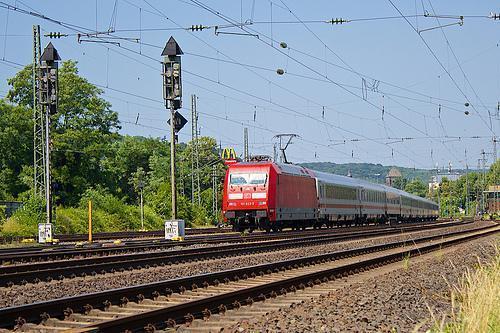How many trains are there?
Give a very brief answer. 1. 